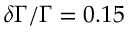<formula> <loc_0><loc_0><loc_500><loc_500>\delta \Gamma / \Gamma = 0 . 1 5</formula> 